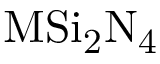<formula> <loc_0><loc_0><loc_500><loc_500>M S i _ { 2 } N _ { 4 }</formula> 